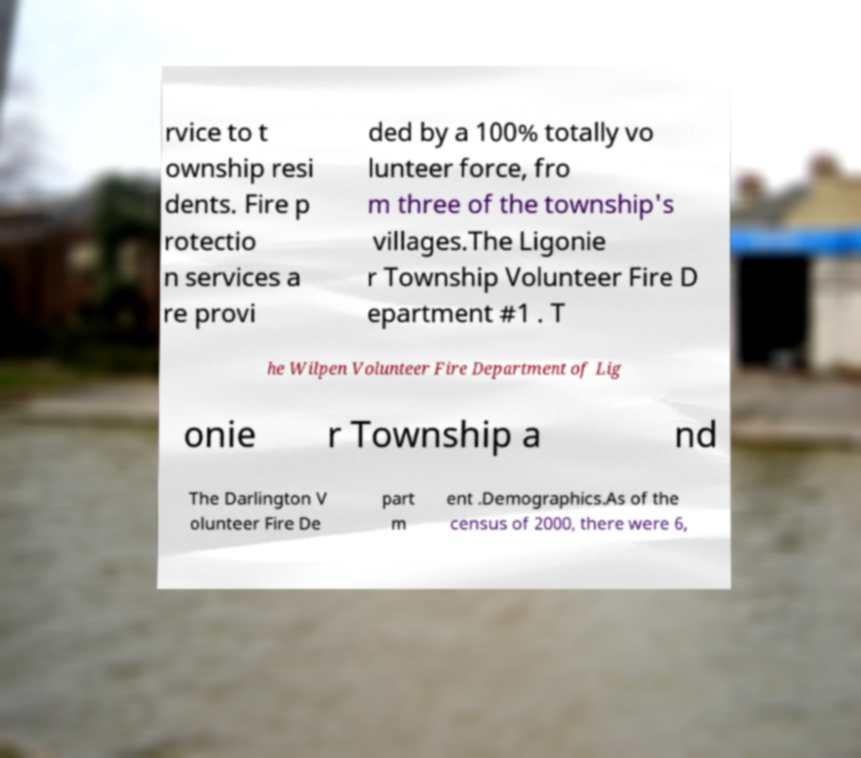I need the written content from this picture converted into text. Can you do that? rvice to t ownship resi dents. Fire p rotectio n services a re provi ded by a 100% totally vo lunteer force, fro m three of the township's villages.The Ligonie r Township Volunteer Fire D epartment #1 . T he Wilpen Volunteer Fire Department of Lig onie r Township a nd The Darlington V olunteer Fire De part m ent .Demographics.As of the census of 2000, there were 6, 